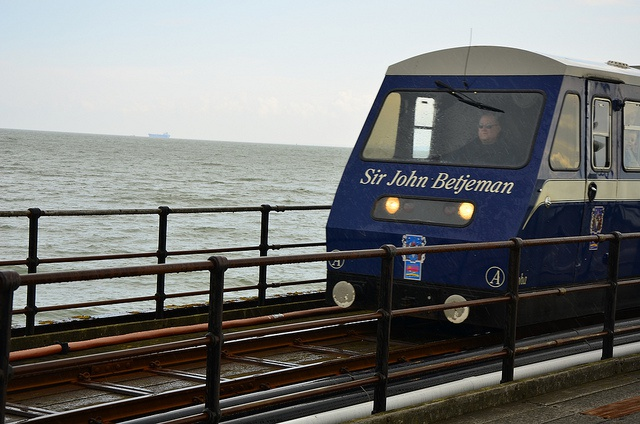Describe the objects in this image and their specific colors. I can see train in lightblue, black, gray, navy, and darkgray tones, people in lightblue, gray, and black tones, and people in lightblue, darkgray, and gray tones in this image. 